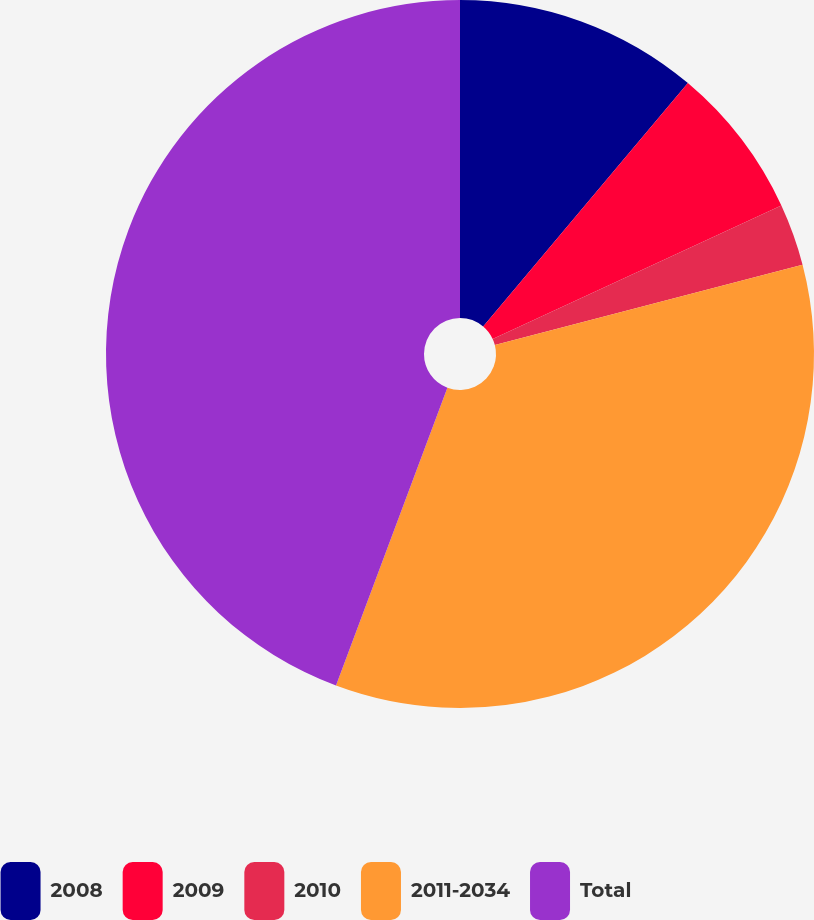Convert chart. <chart><loc_0><loc_0><loc_500><loc_500><pie_chart><fcel>2008<fcel>2009<fcel>2010<fcel>2011-2034<fcel>Total<nl><fcel>11.13%<fcel>6.98%<fcel>2.83%<fcel>34.75%<fcel>44.3%<nl></chart> 